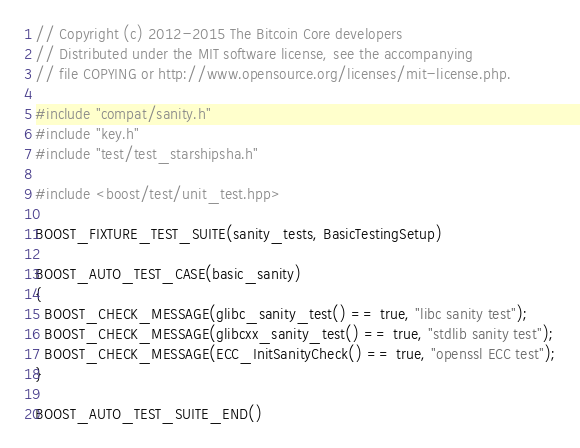<code> <loc_0><loc_0><loc_500><loc_500><_C++_>// Copyright (c) 2012-2015 The Bitcoin Core developers
// Distributed under the MIT software license, see the accompanying
// file COPYING or http://www.opensource.org/licenses/mit-license.php.

#include "compat/sanity.h"
#include "key.h"
#include "test/test_starshipsha.h"

#include <boost/test/unit_test.hpp>

BOOST_FIXTURE_TEST_SUITE(sanity_tests, BasicTestingSetup)

BOOST_AUTO_TEST_CASE(basic_sanity)
{
  BOOST_CHECK_MESSAGE(glibc_sanity_test() == true, "libc sanity test");
  BOOST_CHECK_MESSAGE(glibcxx_sanity_test() == true, "stdlib sanity test");
  BOOST_CHECK_MESSAGE(ECC_InitSanityCheck() == true, "openssl ECC test");
}

BOOST_AUTO_TEST_SUITE_END()
</code> 